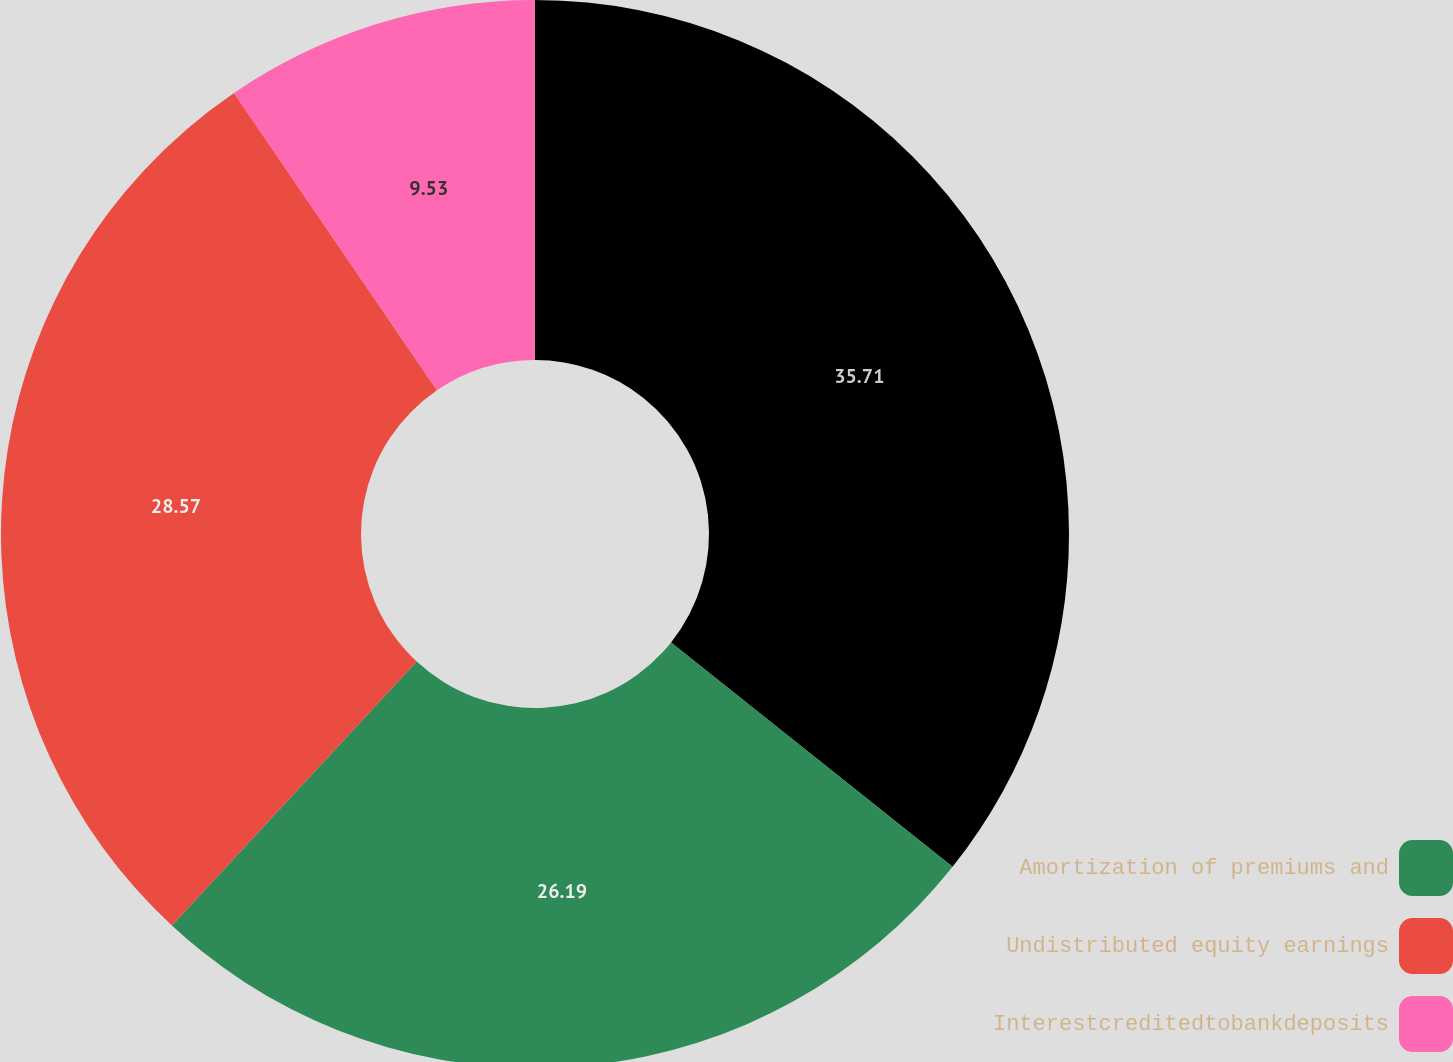Convert chart. <chart><loc_0><loc_0><loc_500><loc_500><pie_chart><ecel><fcel>Amortization of premiums and<fcel>Undistributed equity earnings<fcel>Interestcreditedtobankdeposits<nl><fcel>35.71%<fcel>26.19%<fcel>28.57%<fcel>9.53%<nl></chart> 